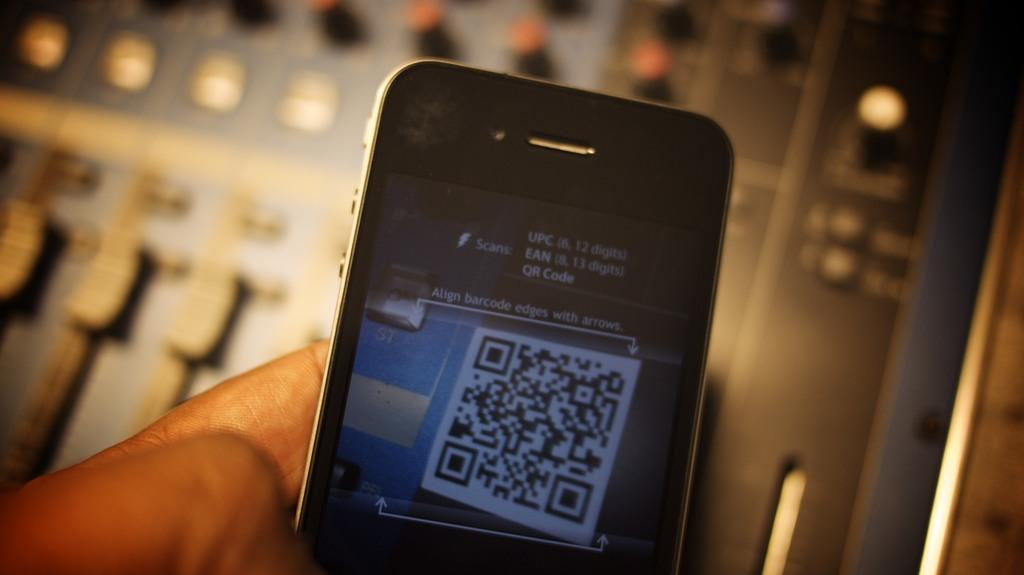<image>
Write a terse but informative summary of the picture. A phone is held is held up in the process of performing a scan with UPC, EAN and QR code prompt and alignment instruction. 